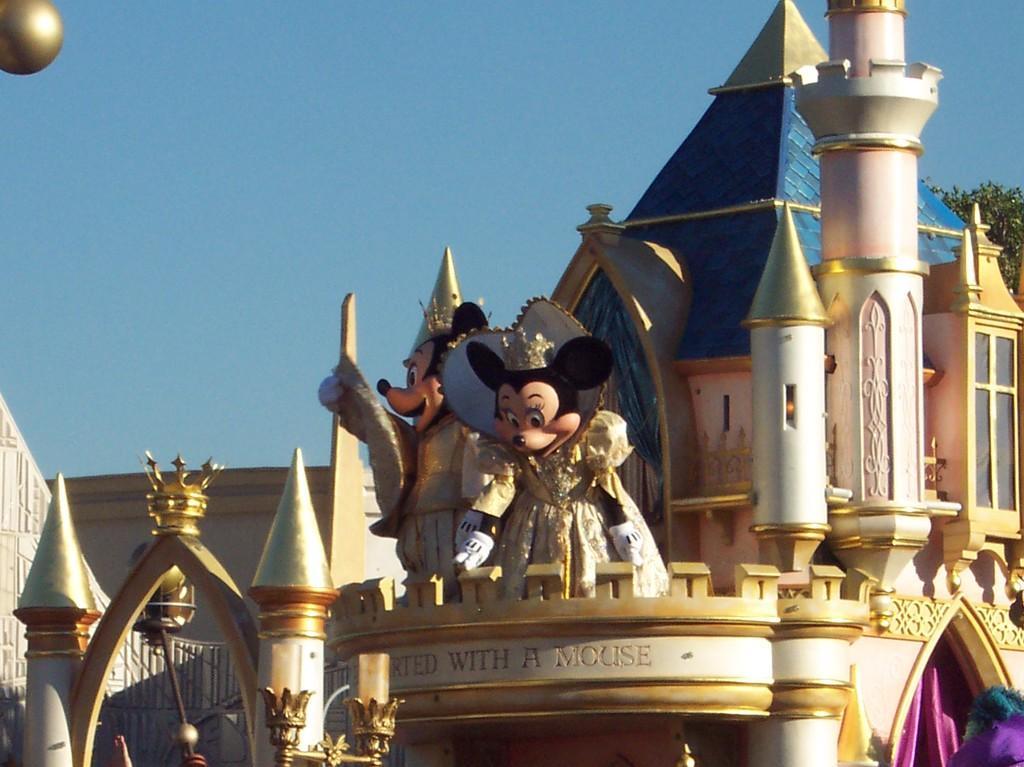Can you describe this image briefly? In this picture we can see a building, cloth, statues, leaves and in the background we can see the sky. 